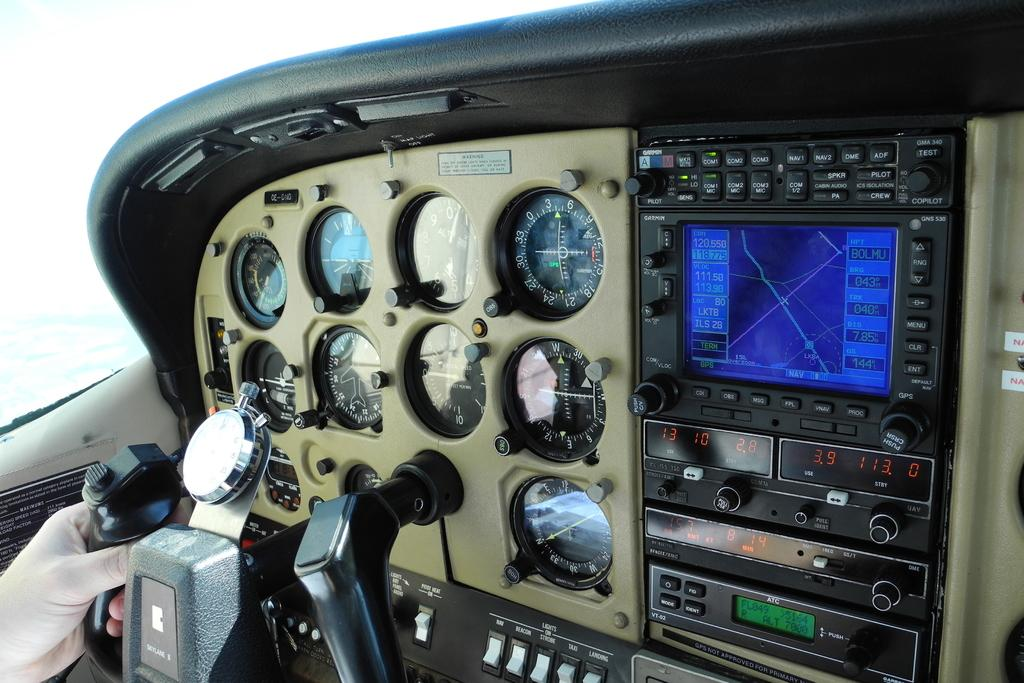What type of location is depicted in the image? The image shows an inside view of an aircraft. What instruments are visible in the image? There are speed-o-meters in the image. What device is present for displaying information? There is a screen in the image. What object can be used to control or adjust something? There is a handle in the image. Whose hand is holding the handle in the image? A person's hand is holding the handle in the image. What type of quilt is being used to cover the screen in the image? There is no quilt present in the image; it features an inside view of an aircraft with a screen and other instruments. How many quinces are visible on the handle in the image? There are no quinces present in the image, and the handle is being held by a person's hand. 